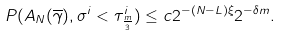<formula> <loc_0><loc_0><loc_500><loc_500>P ( A _ { N } ( \overline { \gamma } ) , \sigma ^ { i } < \tau ^ { i } _ { \frac { m } { 3 } } ) \leq c 2 ^ { - ( N - L ) \xi } 2 ^ { - \delta m } .</formula> 